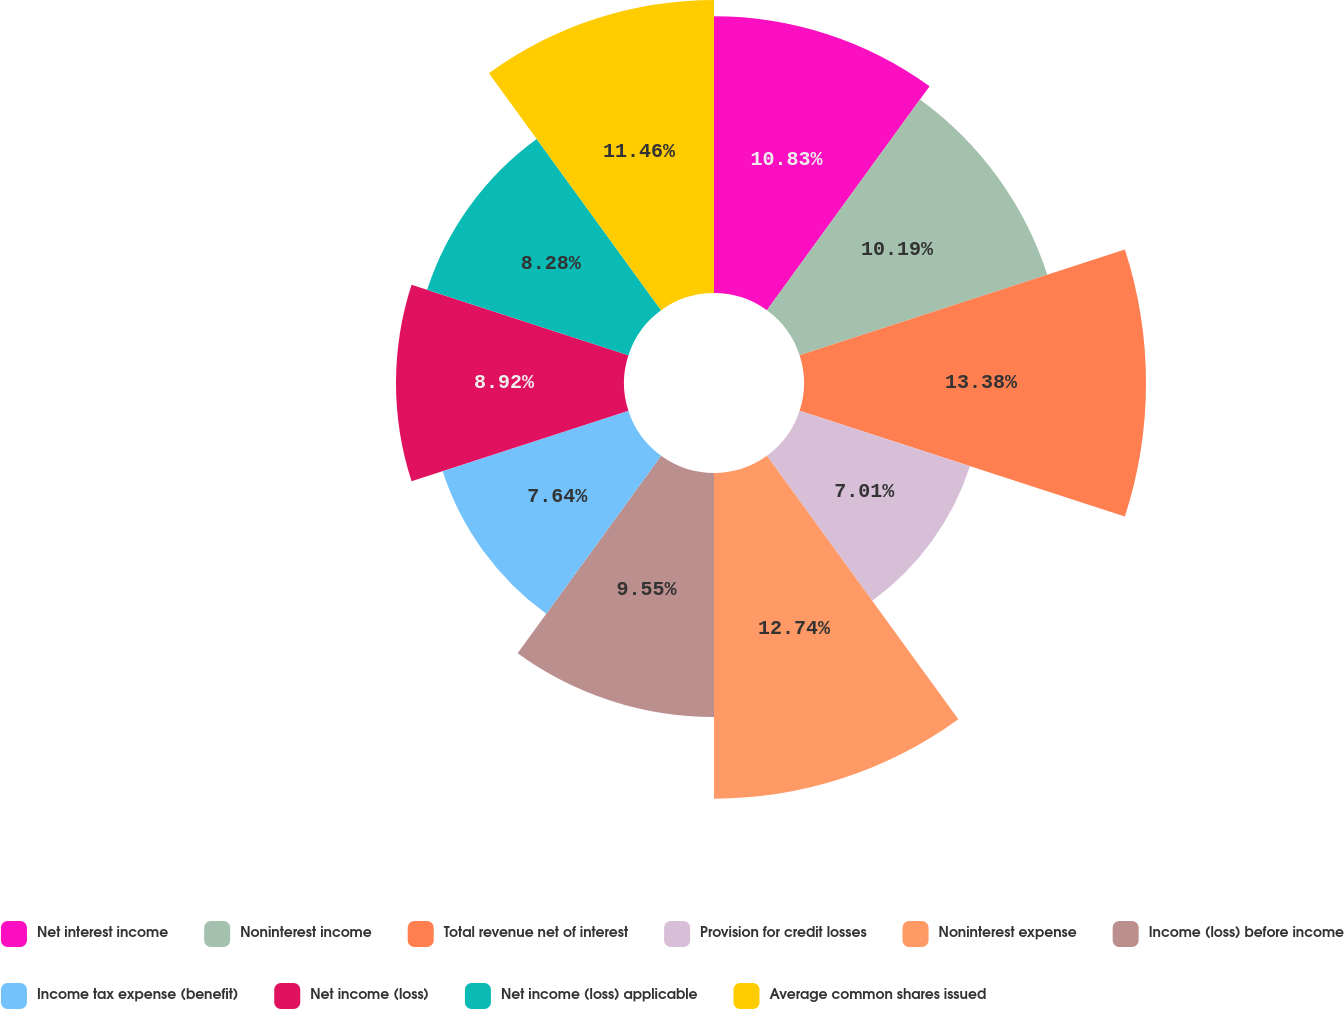Convert chart. <chart><loc_0><loc_0><loc_500><loc_500><pie_chart><fcel>Net interest income<fcel>Noninterest income<fcel>Total revenue net of interest<fcel>Provision for credit losses<fcel>Noninterest expense<fcel>Income (loss) before income<fcel>Income tax expense (benefit)<fcel>Net income (loss)<fcel>Net income (loss) applicable<fcel>Average common shares issued<nl><fcel>10.83%<fcel>10.19%<fcel>13.38%<fcel>7.01%<fcel>12.74%<fcel>9.55%<fcel>7.64%<fcel>8.92%<fcel>8.28%<fcel>11.46%<nl></chart> 